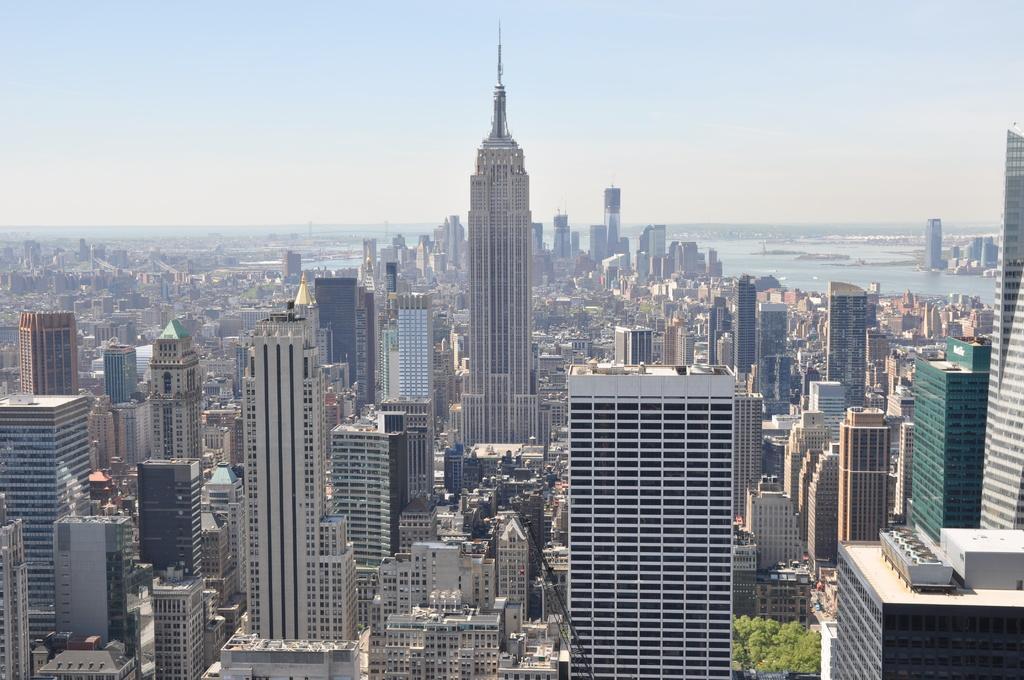How would you summarize this image in a sentence or two? This image is an aerial view. In this image there are buildings and trees. In the background there is water and we can see hills. At the top there is sky. 